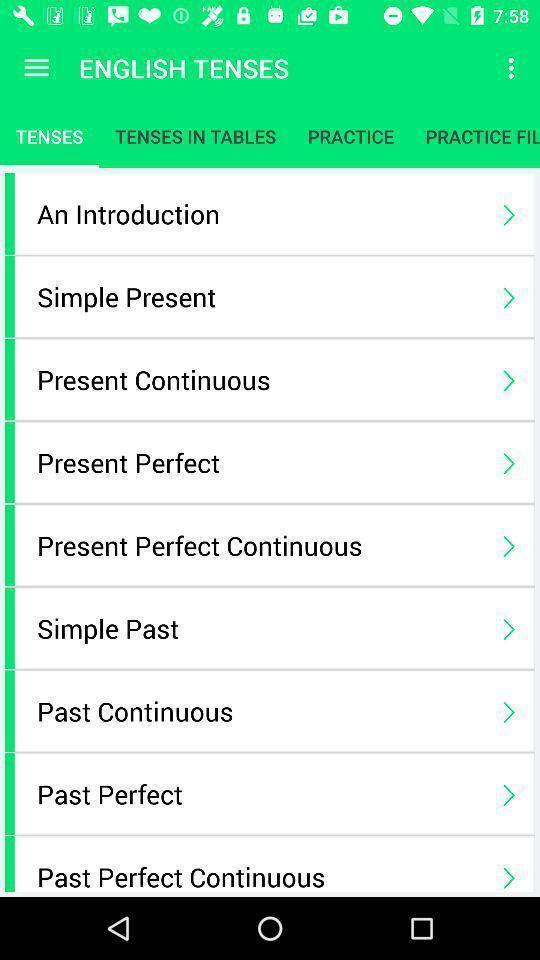Tell me what you see in this picture. Page showing english vocabulary list in learning app. 